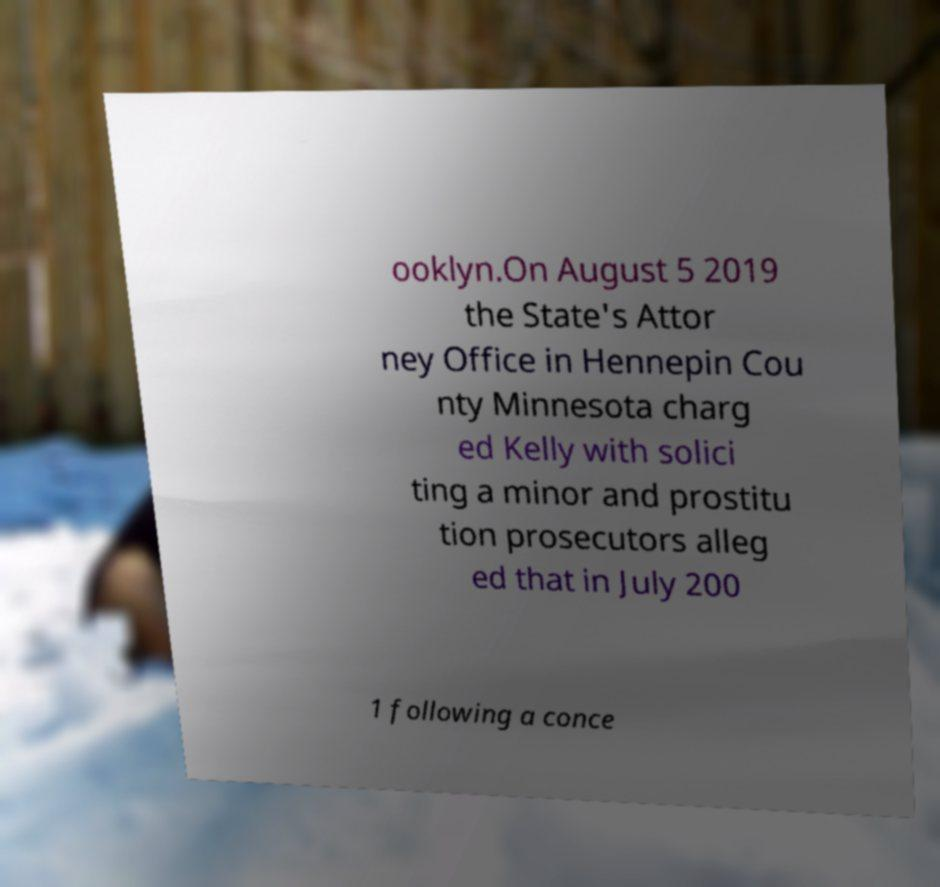There's text embedded in this image that I need extracted. Can you transcribe it verbatim? ooklyn.On August 5 2019 the State's Attor ney Office in Hennepin Cou nty Minnesota charg ed Kelly with solici ting a minor and prostitu tion prosecutors alleg ed that in July 200 1 following a conce 